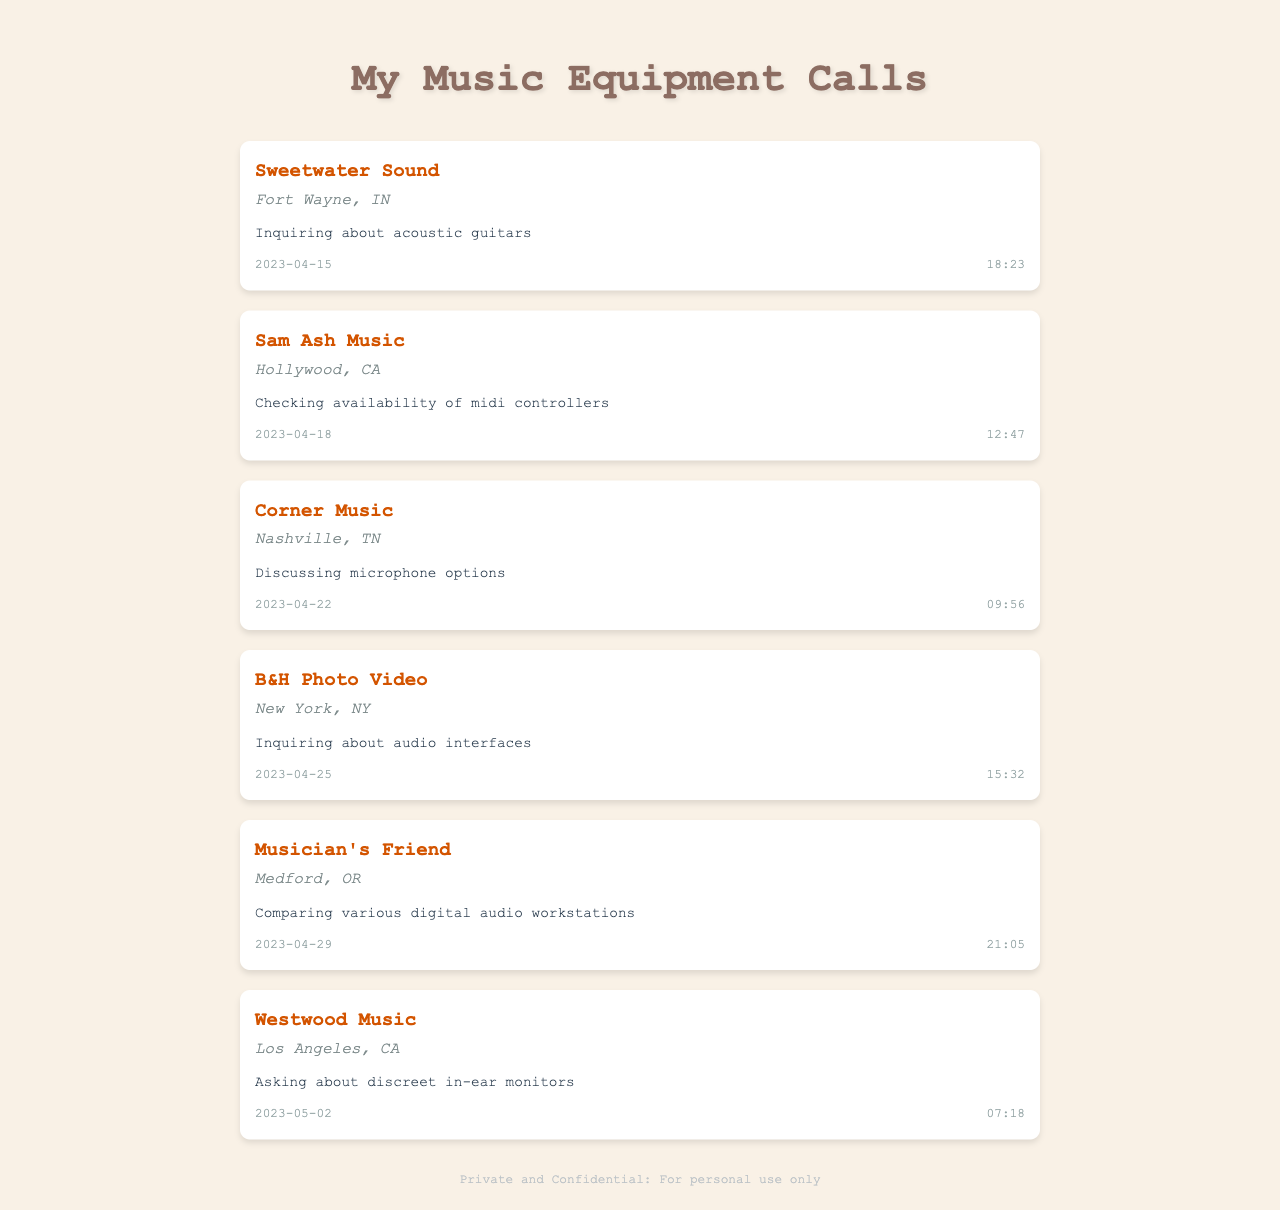What company was contacted about acoustic guitars? The company listed for inquiring about acoustic guitars is Sweetwater Sound.
Answer: Sweetwater Sound How many minutes did the call about audio interfaces last? The duration of the call regarding audio interfaces was 15:32, which can be converted to 15 minutes and 32 seconds.
Answer: 15:32 What is the purpose of the call made to Sam Ash Music? The purpose of the call to Sam Ash Music was to check the availability of midi controllers.
Answer: Checking availability of midi controllers Which location is associated with Corner Music? The location for Corner Music is Nashville, TN.
Answer: Nashville, TN What date was the call regarding digital audio workstations? The call about comparing various digital audio workstations took place on 2023-04-29.
Answer: 2023-04-29 Which call had the shortest duration? The call with the shortest duration was the one to Westwood Music, lasting 07:18.
Answer: 07:18 What type of equipment was inquired about during the call to B&H Photo Video? The inquiry made during the call to B&H Photo Video was about audio interfaces.
Answer: Audio interfaces Which company is located in Hollywood, CA? The company located in Hollywood, CA is Sam Ash Music.
Answer: Sam Ash Music How many records are shown in the document? The document displays a total of six records from long-distance calls made to music equipment suppliers.
Answer: Six 